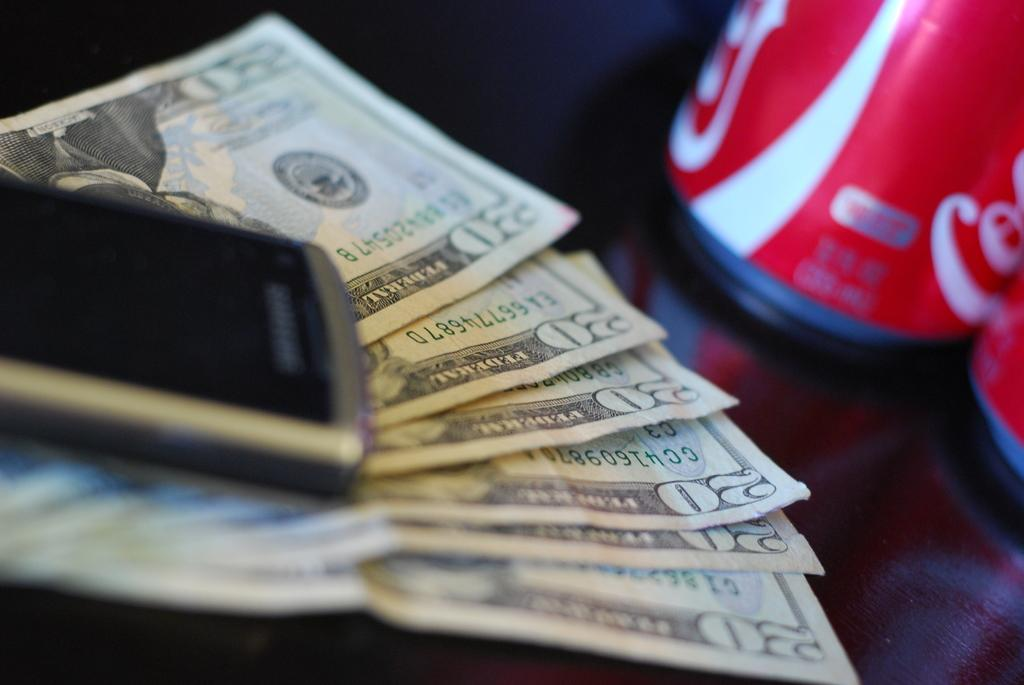<image>
Create a compact narrative representing the image presented. one hundred and twenty dollars under a phone and next to a coke can. 